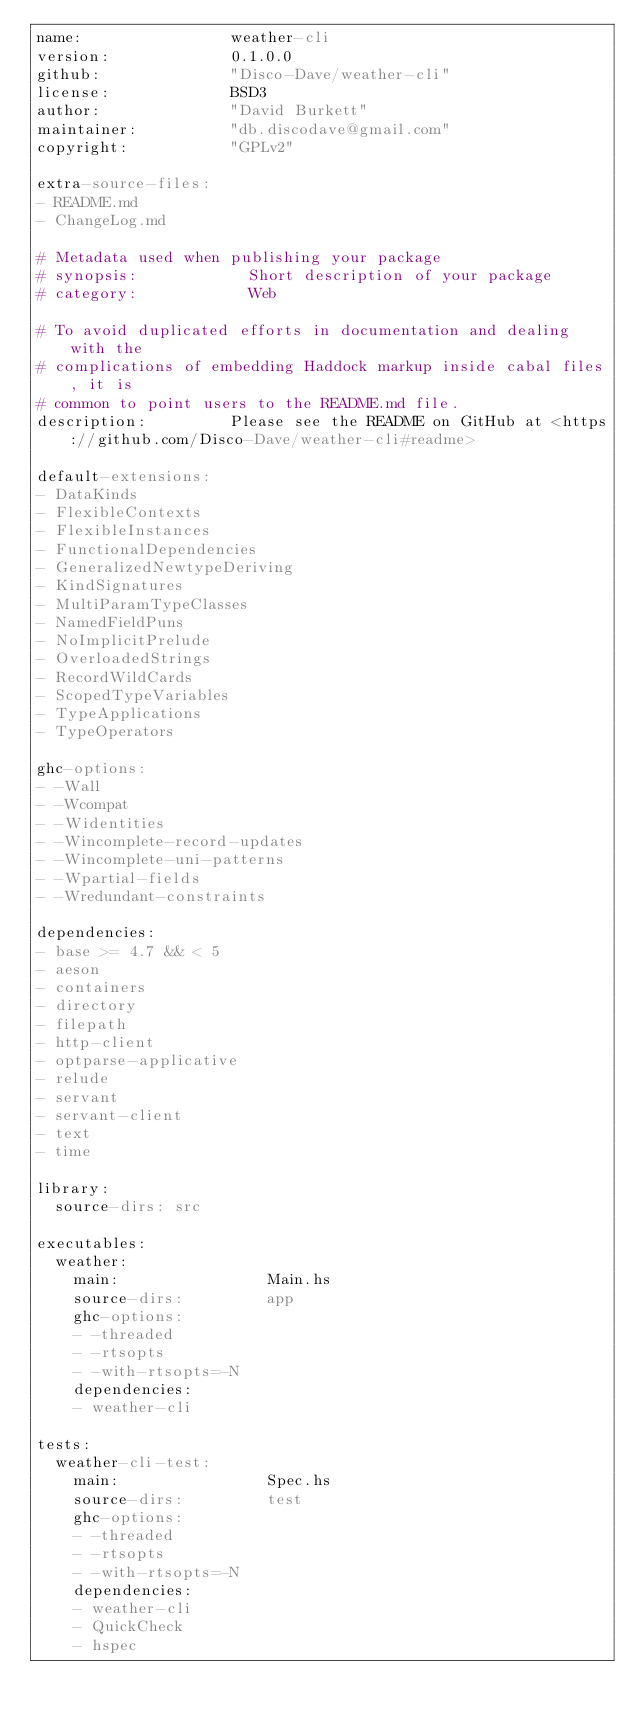<code> <loc_0><loc_0><loc_500><loc_500><_YAML_>name:                weather-cli
version:             0.1.0.0
github:              "Disco-Dave/weather-cli"
license:             BSD3
author:              "David Burkett"
maintainer:          "db.discodave@gmail.com"
copyright:           "GPLv2"

extra-source-files:
- README.md
- ChangeLog.md

# Metadata used when publishing your package
# synopsis:            Short description of your package
# category:            Web

# To avoid duplicated efforts in documentation and dealing with the
# complications of embedding Haddock markup inside cabal files, it is
# common to point users to the README.md file.
description:         Please see the README on GitHub at <https://github.com/Disco-Dave/weather-cli#readme>

default-extensions:
- DataKinds
- FlexibleContexts
- FlexibleInstances
- FunctionalDependencies
- GeneralizedNewtypeDeriving
- KindSignatures
- MultiParamTypeClasses
- NamedFieldPuns
- NoImplicitPrelude
- OverloadedStrings
- RecordWildCards
- ScopedTypeVariables
- TypeApplications
- TypeOperators

ghc-options:
- -Wall
- -Wcompat
- -Widentities
- -Wincomplete-record-updates
- -Wincomplete-uni-patterns
- -Wpartial-fields
- -Wredundant-constraints

dependencies:
- base >= 4.7 && < 5
- aeson
- containers
- directory
- filepath
- http-client
- optparse-applicative
- relude
- servant
- servant-client
- text
- time

library:
  source-dirs: src

executables:
  weather:
    main:                Main.hs
    source-dirs:         app
    ghc-options:
    - -threaded
    - -rtsopts
    - -with-rtsopts=-N
    dependencies:
    - weather-cli

tests:
  weather-cli-test:
    main:                Spec.hs
    source-dirs:         test
    ghc-options:
    - -threaded
    - -rtsopts
    - -with-rtsopts=-N
    dependencies:
    - weather-cli
    - QuickCheck
    - hspec
</code> 